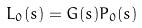<formula> <loc_0><loc_0><loc_500><loc_500>L _ { 0 } ( s ) = G ( s ) P _ { 0 } ( s )</formula> 